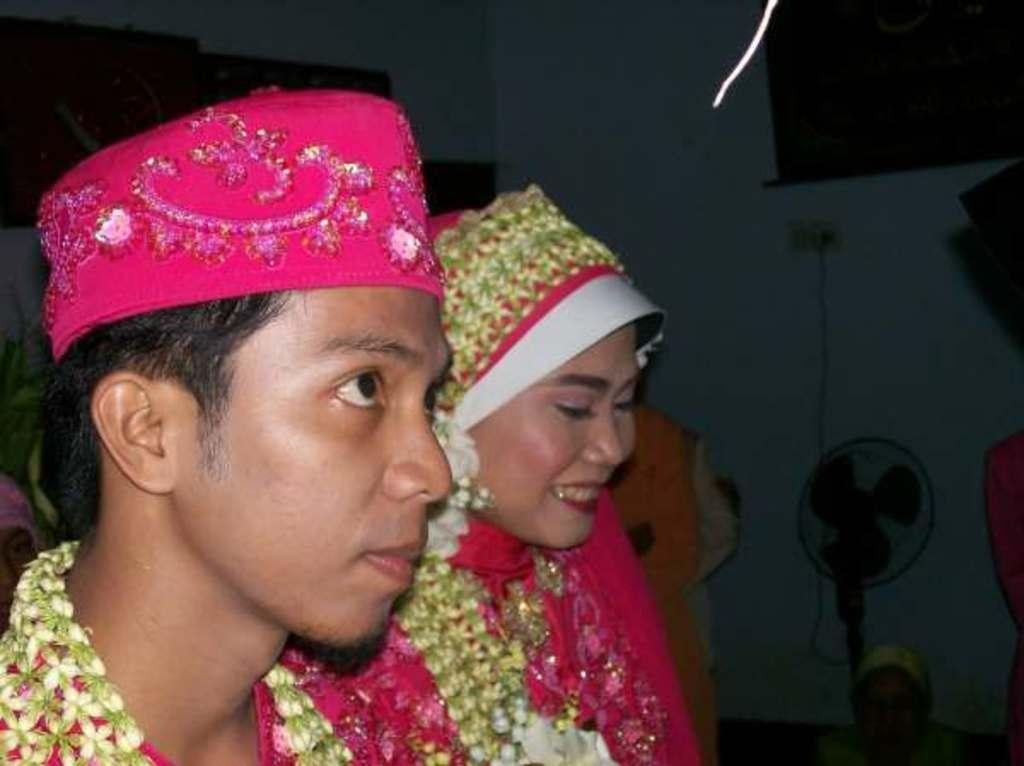Can you describe this image briefly? There is a bride and a bride groom. And the man is wearing a cap. In the back there is a wall. Near to that there is a fan. 